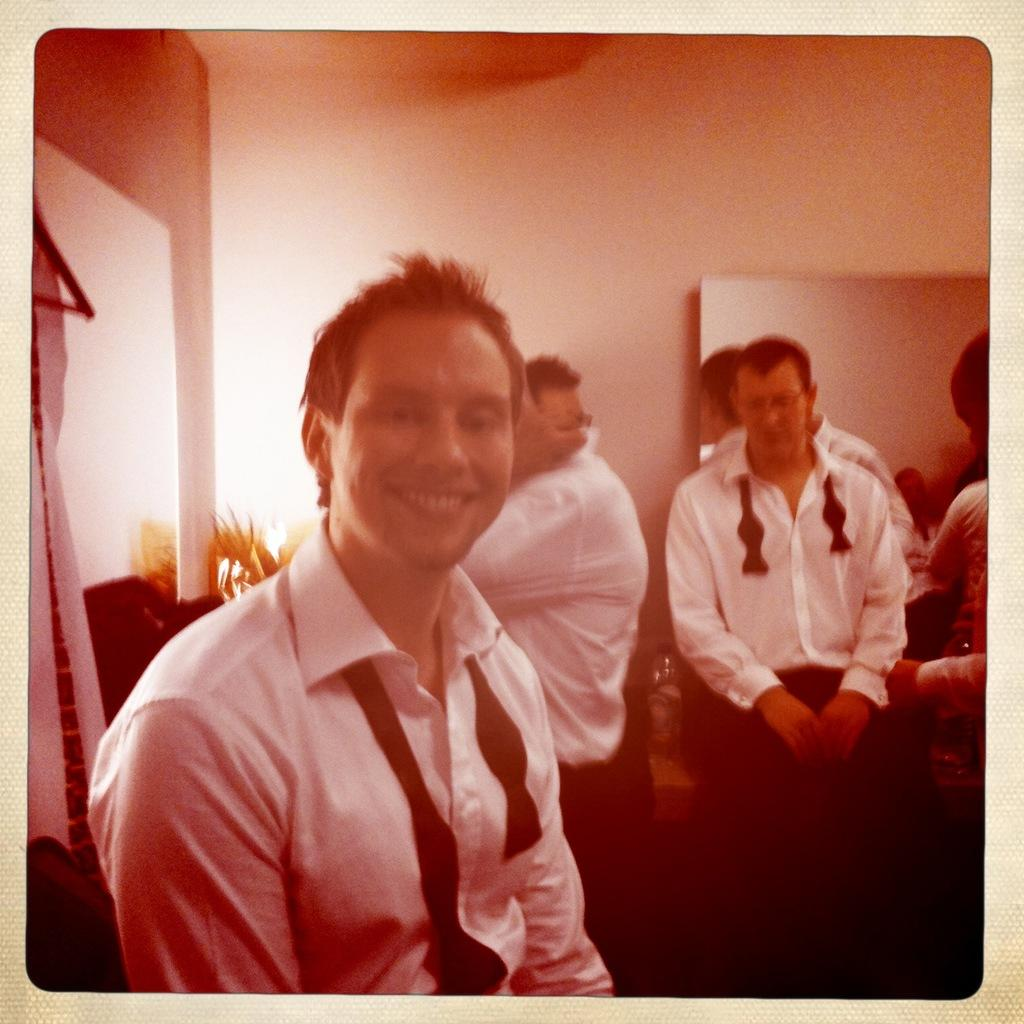What type of image is being described? The image is a photo. Who or what is present in the photo? There are people in the photo. Where are the people located? The people are in a room. What else can be seen in the room besides the people? There are objects in the room. What can be seen in the background of the photo? There is a wall visible in the background of the photo. What arithmetic problem is being solved by the people in the photo? There is no arithmetic problem being solved in the photo; it only shows people in a room. What type of play is being depicted in the photo? There is no play being depicted in the photo; it only shows people in a room. 